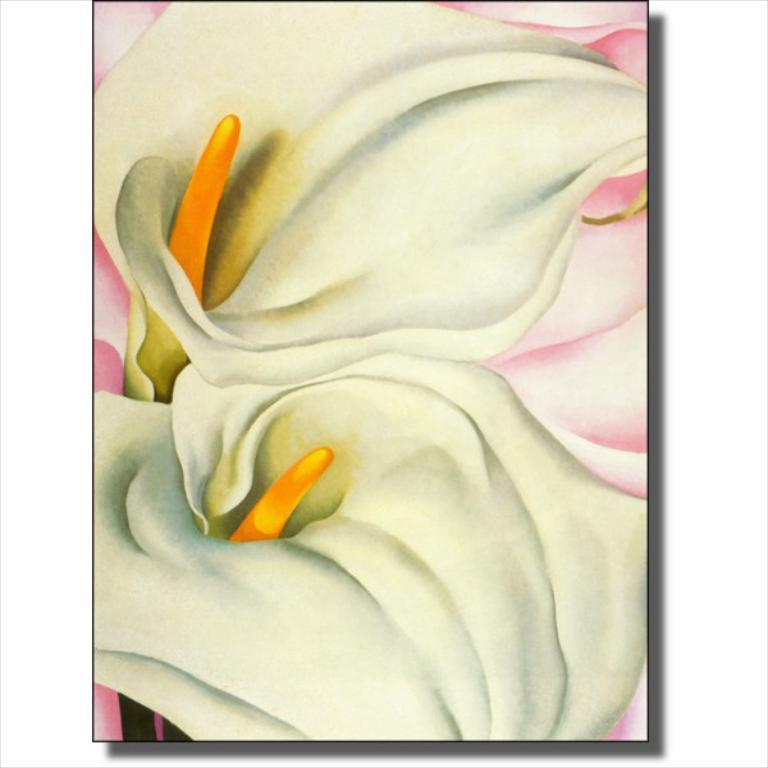How has the poster been altered? The poster is edited. What type of flowers are depicted on the poster? There are two white flowers on the poster. What is the color of the stigmas on the flowers? The flowers have orange stigmas. What color is the background of the poster? The background of the poster is pink. How does the poster sort the turkey in the image? There is no turkey present in the image, so it cannot be sorted. What is the temper of the flowers on the poster? The flowers on the poster do not have a temper, as they are inanimate objects. 